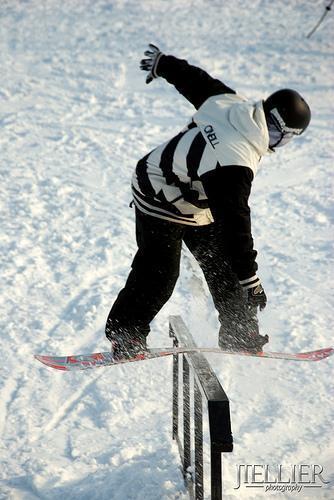How many people are in this photo?
Give a very brief answer. 1. 